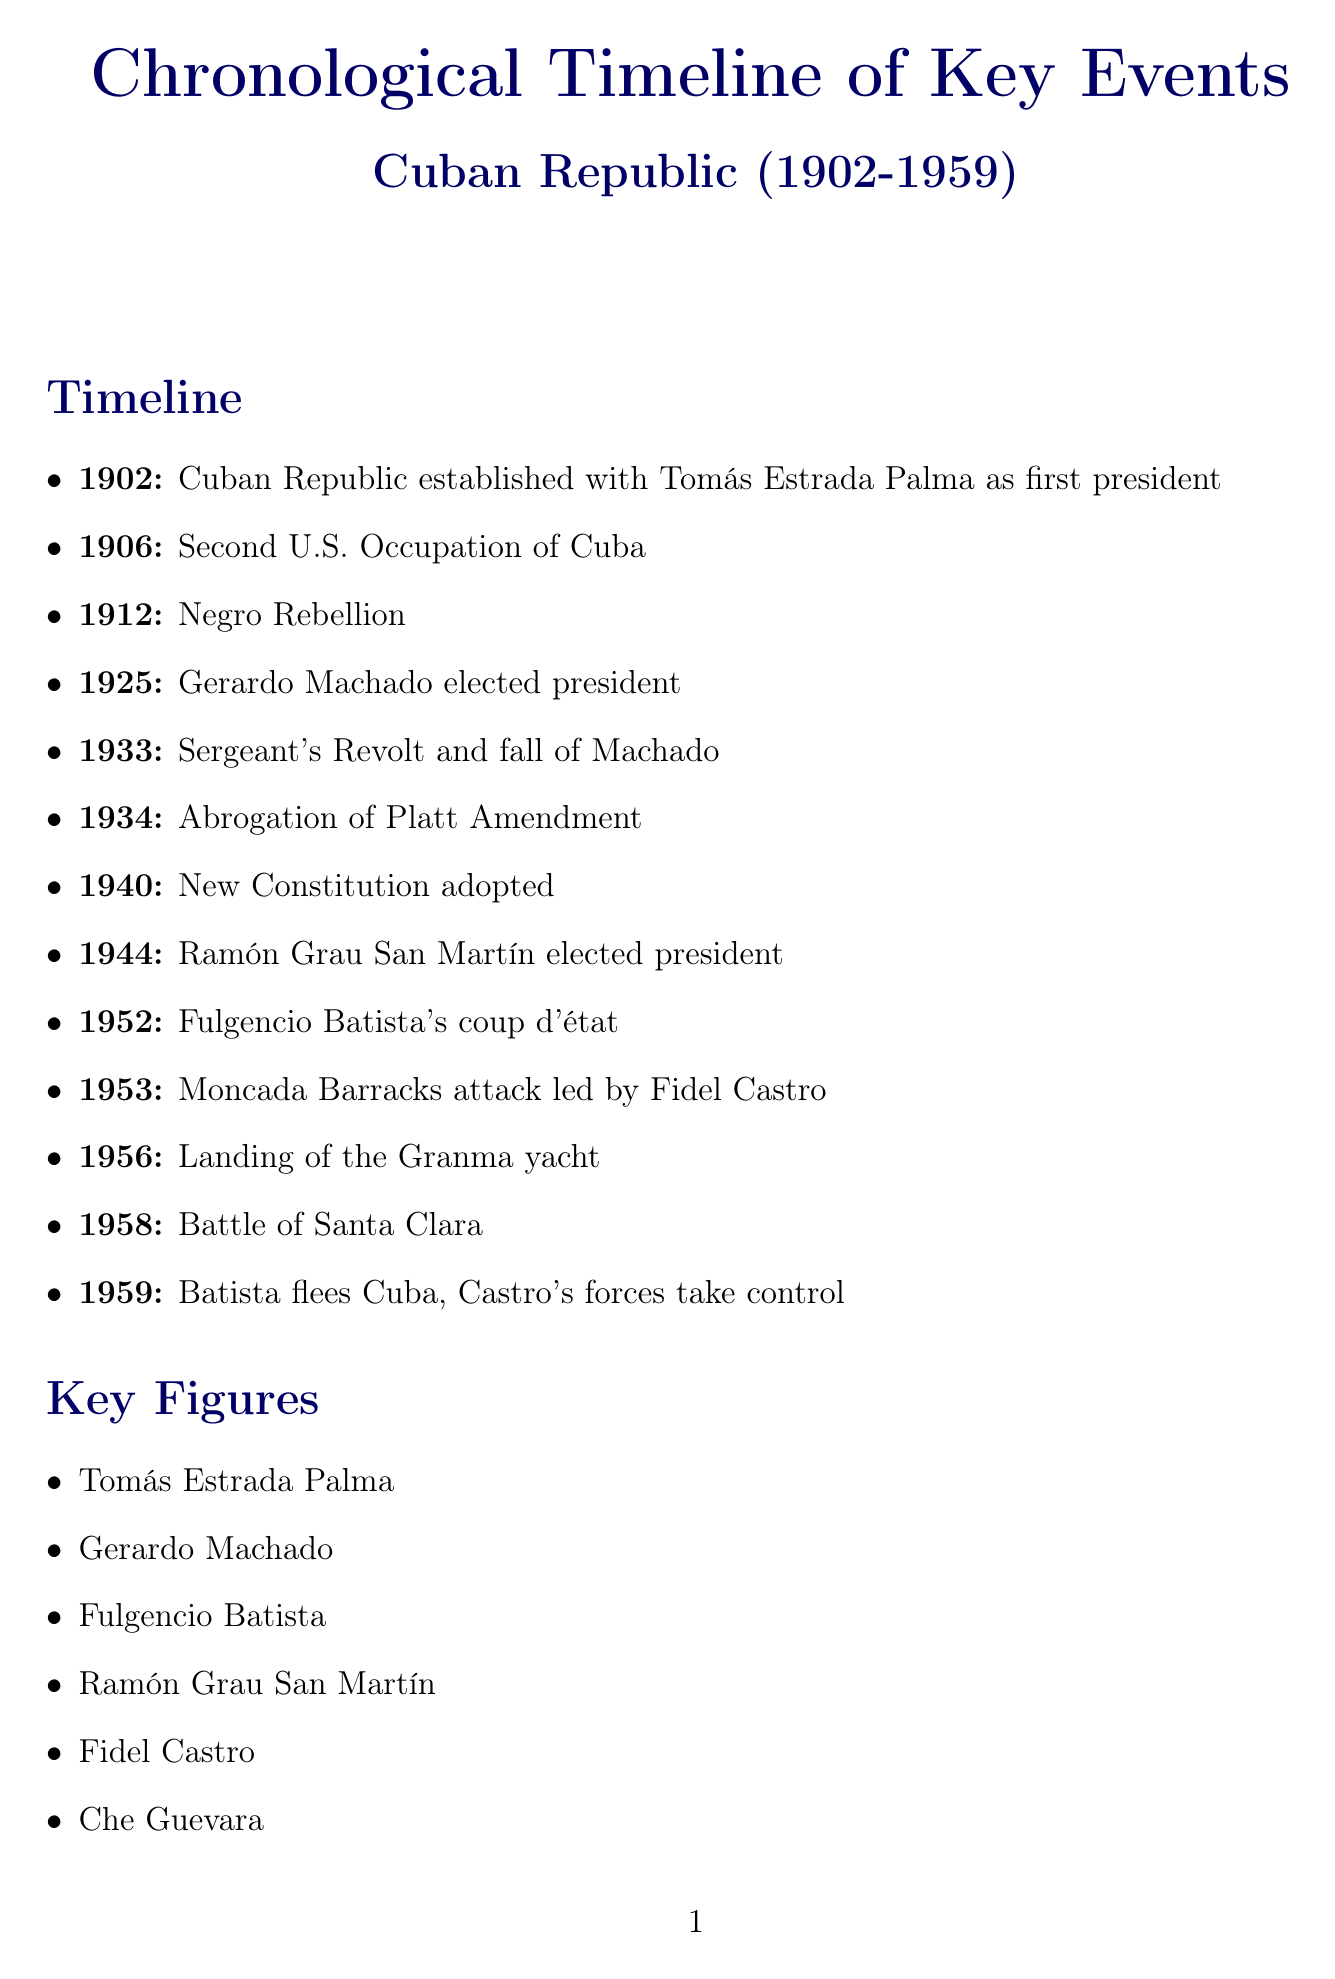What year was the Cuban Republic established? The establishment of the Cuban Republic occurred in 1902.
Answer: 1902 Who was the first president of the Cuban Republic? Tomás Estrada Palma was the first president mentioned in the timeline.
Answer: Tomás Estrada Palma What significant event occurred in 1933? The fall of Machado occurred due to the Sergeant's Revolt, which is a key event listed.
Answer: Sergeant's Revolt and fall of Machado What amendment was abrogated in 1934? The document notes the abrogation of the Platt Amendment, which was significant for increasing Cuban sovereignty.
Answer: Platt Amendment Which key victory for revolutionary forces occurred in 1958? The Battle of Santa Clara is noted as a key victory for revolutionary forces in the timeline.
Answer: Battle of Santa Clara What was a major theme regarding U.S. involvement in Cuba? The theme is explicitly listed as U.S. influence and intervention, which covers the role of the U.S. throughout the Cuban Republic era.
Answer: U.S. influence and intervention How many years was the Cuban Republic established before Batista's coup? Batista's coup occurred in 1952, and the Cuban Republic was established in 1902, so the gap is 50 years.
Answer: 50 years Who returned to civilian rule in 1944? Ramón Grau San Martín is identified as the one who was elected in 1944, marking the return to civilian rule.
Answer: Ramón Grau San Martín 